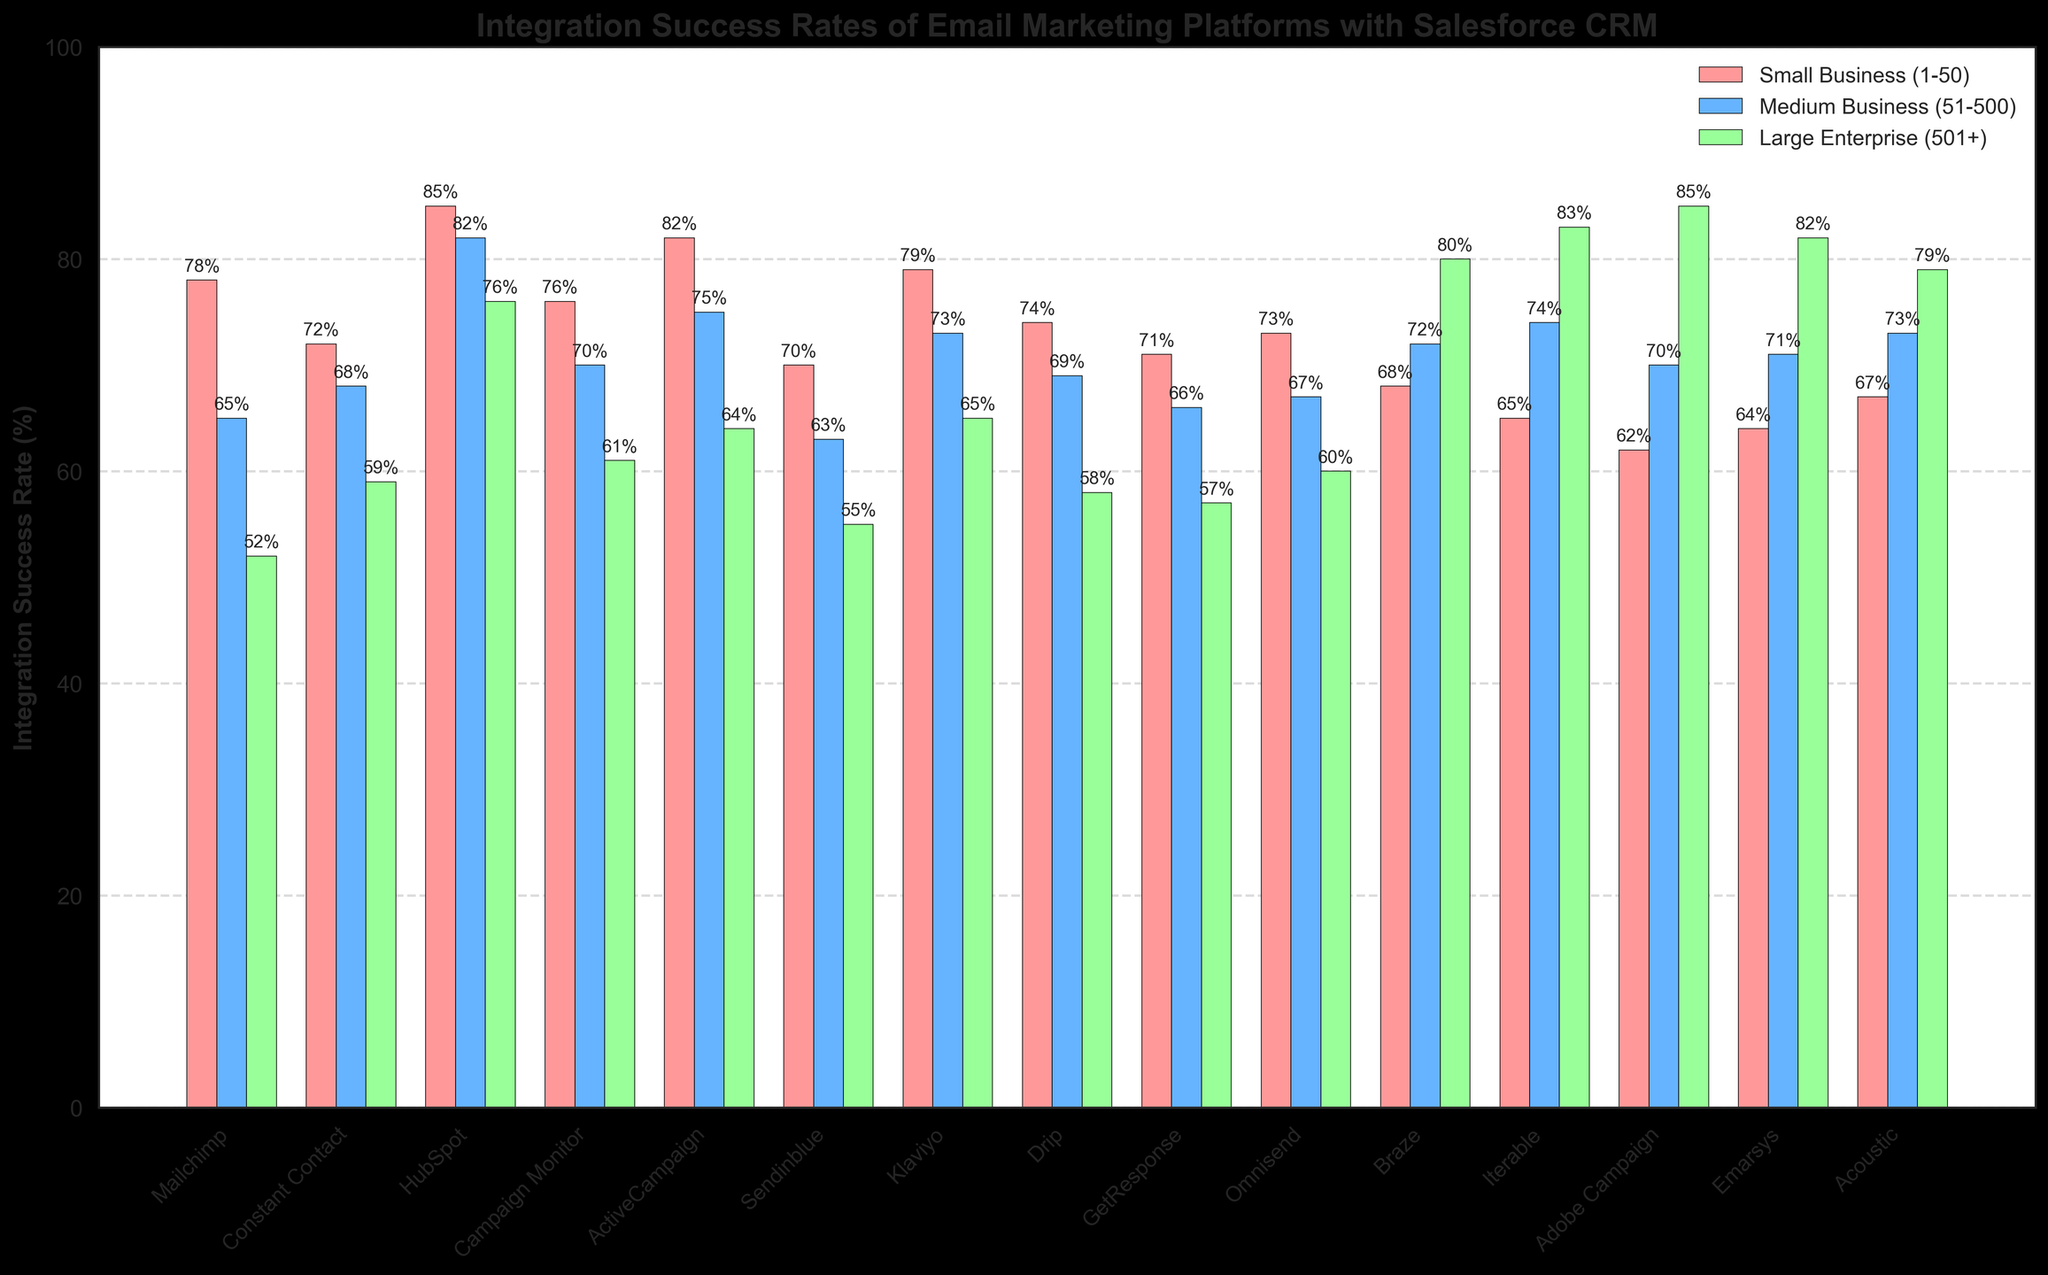Which platform has the highest integration success rate for small businesses (1-50 employees)? To determine the platform with the highest integration success rate for small businesses, look for the tallest bar in the "Small Business (1-50)" category. In this case, HubSpot with 85% is the highest.
Answer: HubSpot Which platform has the lowest integration success rate for medium businesses (51-500 employees)? To find the platform with the lowest integration success rate for medium businesses, look for the shortest bar in the "Medium Business (51-500)" category. In this case, Sendinblue with 63% is the lowest.
Answer: Sendinblue How much higher is the integration success rate of Adobe Campaign for large enterprises compared to small businesses? Find the integration success rates of Adobe Campaign for small businesses (62%) and large enterprises (85%). Subtract the small business rate from the large enterprise rate: 85% - 62% = 23%.
Answer: 23% Which platform has the greatest difference in integration success rates between small businesses and large enterprises? Calculate the absolute differences in success rates between small businesses and large enterprises for each platform. Adobe Campaign has a difference of 85% - 62% = 23%, which is the greatest difference among all platforms.
Answer: Adobe Campaign Compare the integration success rates of HubSpot and Campaign Monitor for medium businesses and identify which has a higher success rate and by how much. HubSpot's success rate for medium businesses is 82%, and Campaign Monitor's is 70%. The difference is 82% - 70% = 12%, making HubSpot the higher of the two by 12%.
Answer: HubSpot by 12% Which platform performs consistently well across all three company sizes? Look for platforms with higher and close success rates across small businesses, medium businesses, and large enterprises. HubSpot has 85% for small, 82% for medium, and 76% for large enterprises, indicating consistent performance.
Answer: HubSpot Identify the platform with the second-highest integration success rate for large enterprises (501+ employees). Look for the bar with the second tallest height in the "Large Enterprise (501+)" category. Emarsys with an 82% success rate is the second highest.
Answer: Emarsys What is the average integration success rate of ActiveCampaign across all company sizes? Calculate the average by summing up ActiveCampaign's success rates across all sizes (82% + 75% + 64%) and dividing by 3: (82 + 75 + 64) / 3 = 73.67%.
Answer: 73.67% Compare the integration success rates of Klaviyo and Drip for small businesses (1-50 employees) and state the difference. Klaviyo's rate is 79% and Drip's is 74%. The difference is 79% - 74% = 5%.
Answer: 5% Which platform has a higher integration success rate for medium businesses, Braze or Iterable? Check the bars for medium businesses (51-500). Braze has a 72% rate, and Iterable has a 74% rate, making Iterable higher.
Answer: Iterable 